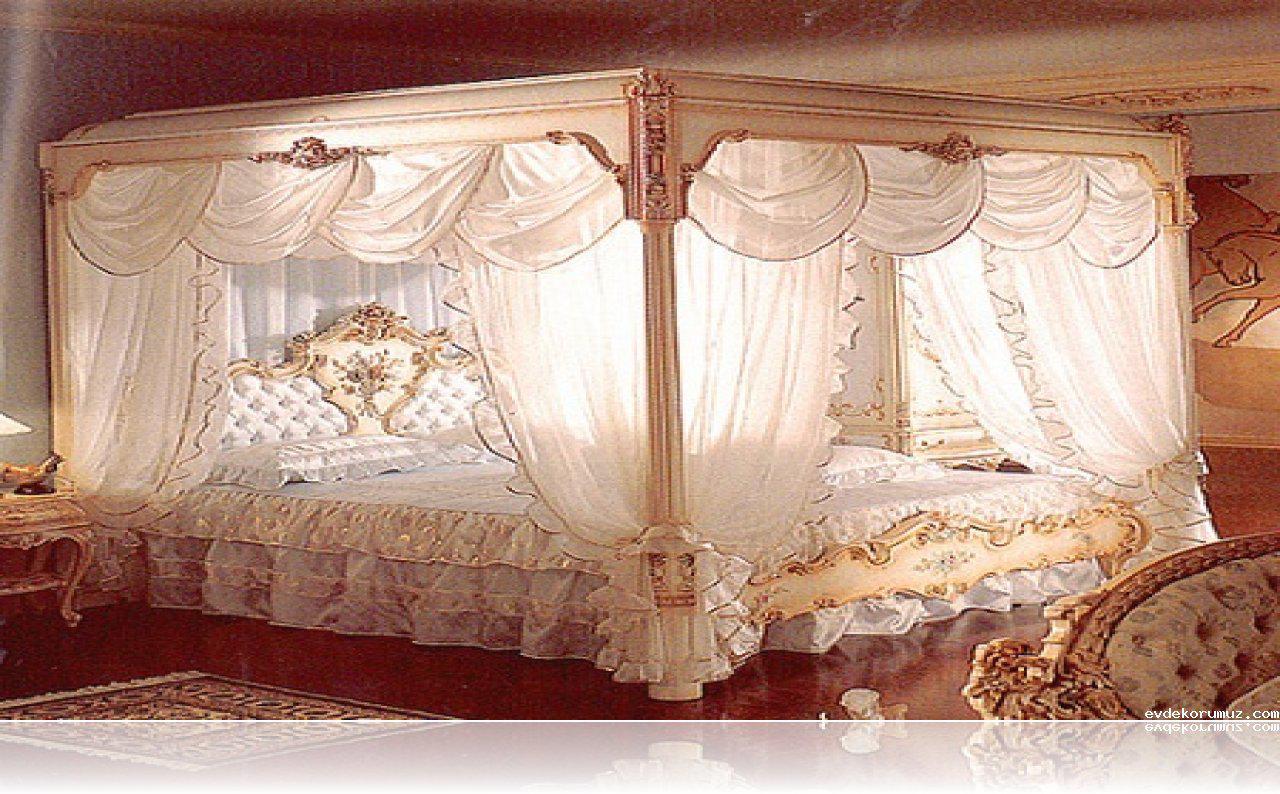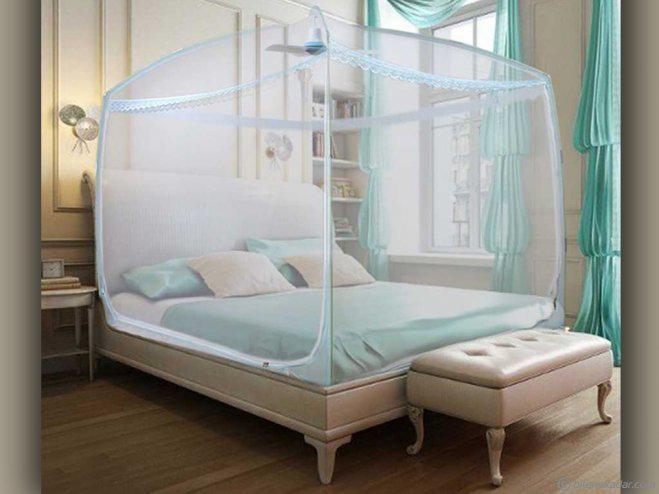The first image is the image on the left, the second image is the image on the right. For the images displayed, is the sentence "At least one bed net is pink." factually correct? Answer yes or no. No. The first image is the image on the left, the second image is the image on the right. Assess this claim about the two images: "At least one image shows a gauzy canopy that drapes a bed from a round shape suspended from the ceiling, and at least one image features a pink canopy draping a bed.". Correct or not? Answer yes or no. No. 